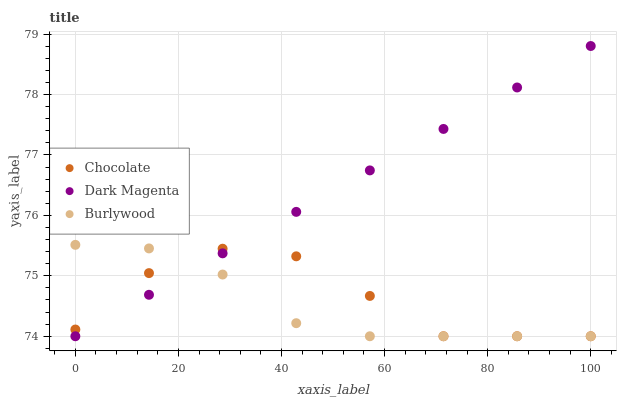Does Burlywood have the minimum area under the curve?
Answer yes or no. Yes. Does Dark Magenta have the maximum area under the curve?
Answer yes or no. Yes. Does Chocolate have the minimum area under the curve?
Answer yes or no. No. Does Chocolate have the maximum area under the curve?
Answer yes or no. No. Is Dark Magenta the smoothest?
Answer yes or no. Yes. Is Chocolate the roughest?
Answer yes or no. Yes. Is Chocolate the smoothest?
Answer yes or no. No. Is Dark Magenta the roughest?
Answer yes or no. No. Does Burlywood have the lowest value?
Answer yes or no. Yes. Does Dark Magenta have the highest value?
Answer yes or no. Yes. Does Chocolate have the highest value?
Answer yes or no. No. Does Chocolate intersect Dark Magenta?
Answer yes or no. Yes. Is Chocolate less than Dark Magenta?
Answer yes or no. No. Is Chocolate greater than Dark Magenta?
Answer yes or no. No. 